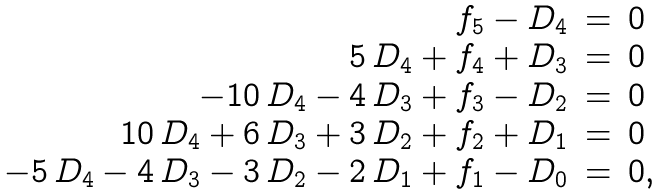<formula> <loc_0><loc_0><loc_500><loc_500>\begin{array} { r c l } f _ { 5 } - D _ { 4 } & = & 0 \\ 5 \, D _ { 4 } + f _ { 4 } + D _ { 3 } & = & 0 \\ - 1 0 \, D _ { 4 } - 4 \, D _ { 3 } + f _ { 3 } - D _ { 2 } & = & 0 \\ 1 0 \, D _ { 4 } + 6 \, D _ { 3 } + 3 \, D _ { 2 } + f _ { 2 } + D _ { 1 } & = & 0 \\ - 5 \, D _ { 4 } - 4 \, D _ { 3 } - 3 \, D _ { 2 } - 2 \, D _ { 1 } + f _ { 1 } - D _ { 0 } & = & 0 , \end{array}</formula> 